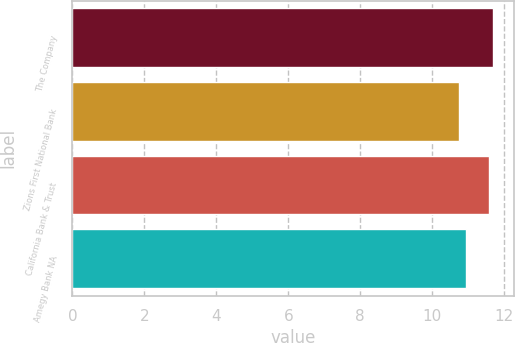Convert chart to OTSL. <chart><loc_0><loc_0><loc_500><loc_500><bar_chart><fcel>The Company<fcel>Zions First National Bank<fcel>California Bank & Trust<fcel>Amegy Bank NA<nl><fcel>11.68<fcel>10.75<fcel>11.58<fcel>10.94<nl></chart> 